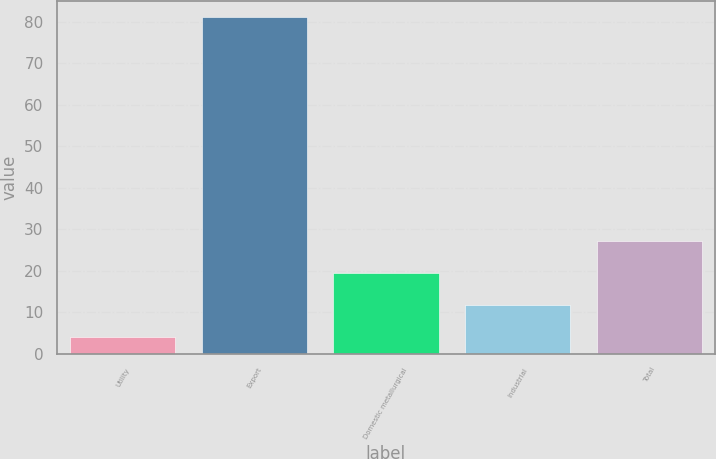Convert chart to OTSL. <chart><loc_0><loc_0><loc_500><loc_500><bar_chart><fcel>Utility<fcel>Export<fcel>Domestic metallurgical<fcel>Industrial<fcel>Total<nl><fcel>4<fcel>81<fcel>19.4<fcel>11.7<fcel>27.1<nl></chart> 